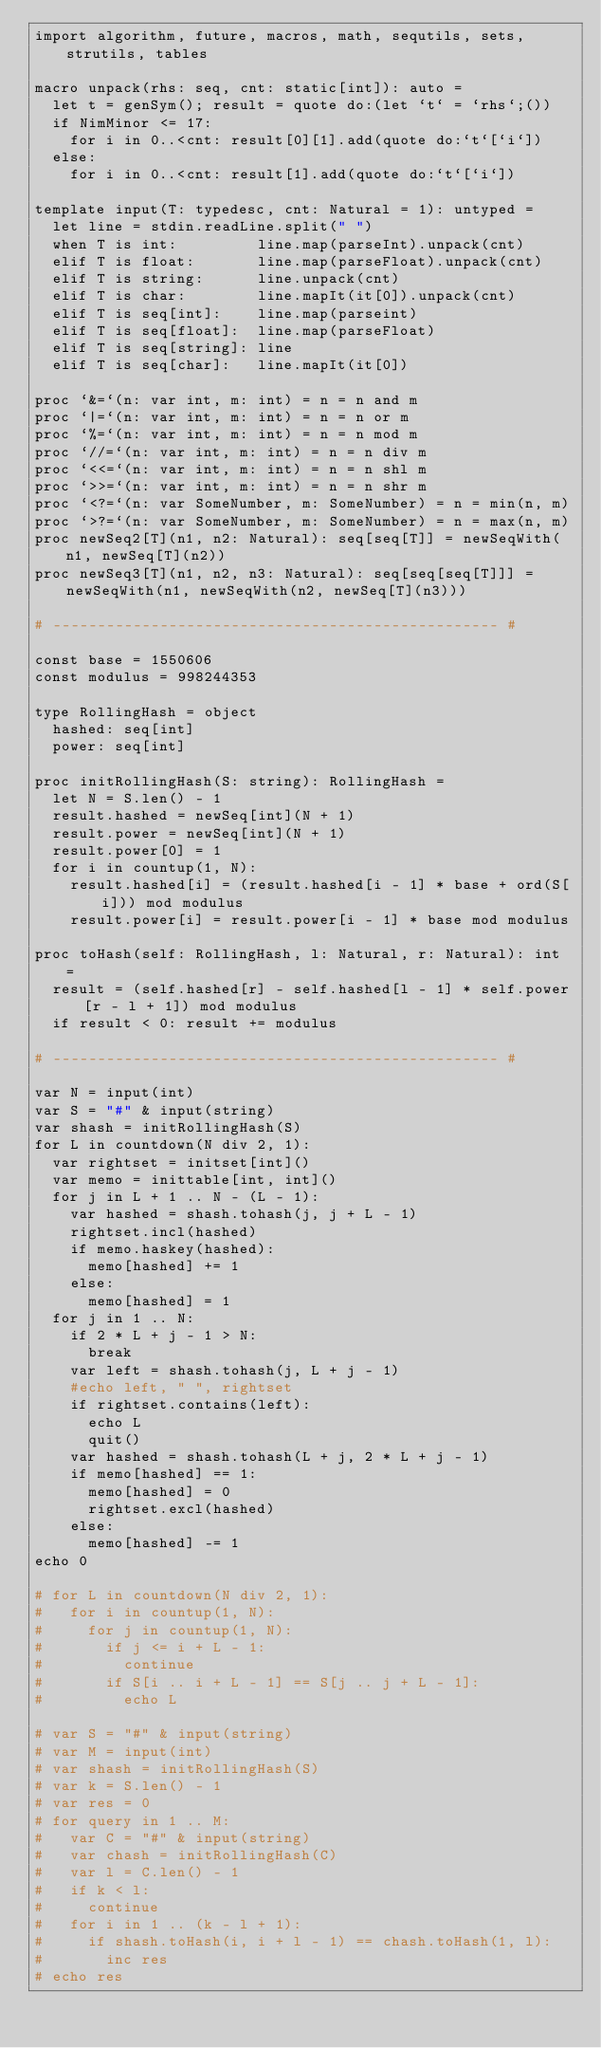Convert code to text. <code><loc_0><loc_0><loc_500><loc_500><_Nim_>import algorithm, future, macros, math, sequtils, sets, strutils, tables

macro unpack(rhs: seq, cnt: static[int]): auto =
  let t = genSym(); result = quote do:(let `t` = `rhs`;())
  if NimMinor <= 17:
    for i in 0..<cnt: result[0][1].add(quote do:`t`[`i`])
  else:
    for i in 0..<cnt: result[1].add(quote do:`t`[`i`])

template input(T: typedesc, cnt: Natural = 1): untyped =
  let line = stdin.readLine.split(" ")
  when T is int:         line.map(parseInt).unpack(cnt)
  elif T is float:       line.map(parseFloat).unpack(cnt)
  elif T is string:      line.unpack(cnt)
  elif T is char:        line.mapIt(it[0]).unpack(cnt)
  elif T is seq[int]:    line.map(parseint)
  elif T is seq[float]:  line.map(parseFloat)
  elif T is seq[string]: line
  elif T is seq[char]:   line.mapIt(it[0])

proc `&=`(n: var int, m: int) = n = n and m
proc `|=`(n: var int, m: int) = n = n or m
proc `%=`(n: var int, m: int) = n = n mod m
proc `//=`(n: var int, m: int) = n = n div m
proc `<<=`(n: var int, m: int) = n = n shl m
proc `>>=`(n: var int, m: int) = n = n shr m
proc `<?=`(n: var SomeNumber, m: SomeNumber) = n = min(n, m)
proc `>?=`(n: var SomeNumber, m: SomeNumber) = n = max(n, m)
proc newSeq2[T](n1, n2: Natural): seq[seq[T]] = newSeqWith(n1, newSeq[T](n2))
proc newSeq3[T](n1, n2, n3: Natural): seq[seq[seq[T]]] = newSeqWith(n1, newSeqWith(n2, newSeq[T](n3)))

# -------------------------------------------------- #

const base = 1550606
const modulus = 998244353

type RollingHash = object
  hashed: seq[int]
  power: seq[int]

proc initRollingHash(S: string): RollingHash =
  let N = S.len() - 1
  result.hashed = newSeq[int](N + 1)
  result.power = newSeq[int](N + 1)
  result.power[0] = 1
  for i in countup(1, N):
    result.hashed[i] = (result.hashed[i - 1] * base + ord(S[i])) mod modulus
    result.power[i] = result.power[i - 1] * base mod modulus

proc toHash(self: RollingHash, l: Natural, r: Natural): int =
  result = (self.hashed[r] - self.hashed[l - 1] * self.power[r - l + 1]) mod modulus
  if result < 0: result += modulus

# -------------------------------------------------- #

var N = input(int)
var S = "#" & input(string)
var shash = initRollingHash(S)
for L in countdown(N div 2, 1):
  var rightset = initset[int]()
  var memo = inittable[int, int]()
  for j in L + 1 .. N - (L - 1):
    var hashed = shash.tohash(j, j + L - 1)
    rightset.incl(hashed)
    if memo.haskey(hashed):
      memo[hashed] += 1
    else:
      memo[hashed] = 1
  for j in 1 .. N:
    if 2 * L + j - 1 > N:
      break
    var left = shash.tohash(j, L + j - 1)
    #echo left, " ", rightset
    if rightset.contains(left):
      echo L
      quit()
    var hashed = shash.tohash(L + j, 2 * L + j - 1)
    if memo[hashed] == 1:
      memo[hashed] = 0
      rightset.excl(hashed)
    else:
      memo[hashed] -= 1
echo 0

# for L in countdown(N div 2, 1):
#   for i in countup(1, N):
#     for j in countup(1, N):
#       if j <= i + L - 1:
#         continue
#       if S[i .. i + L - 1] == S[j .. j + L - 1]:
#         echo L

# var S = "#" & input(string)
# var M = input(int)
# var shash = initRollingHash(S)
# var k = S.len() - 1
# var res = 0
# for query in 1 .. M:
#   var C = "#" & input(string)
#   var chash = initRollingHash(C)
#   var l = C.len() - 1
#   if k < l:
#     continue
#   for i in 1 .. (k - l + 1):
#     if shash.toHash(i, i + l - 1) == chash.toHash(1, l):
#       inc res
# echo res</code> 